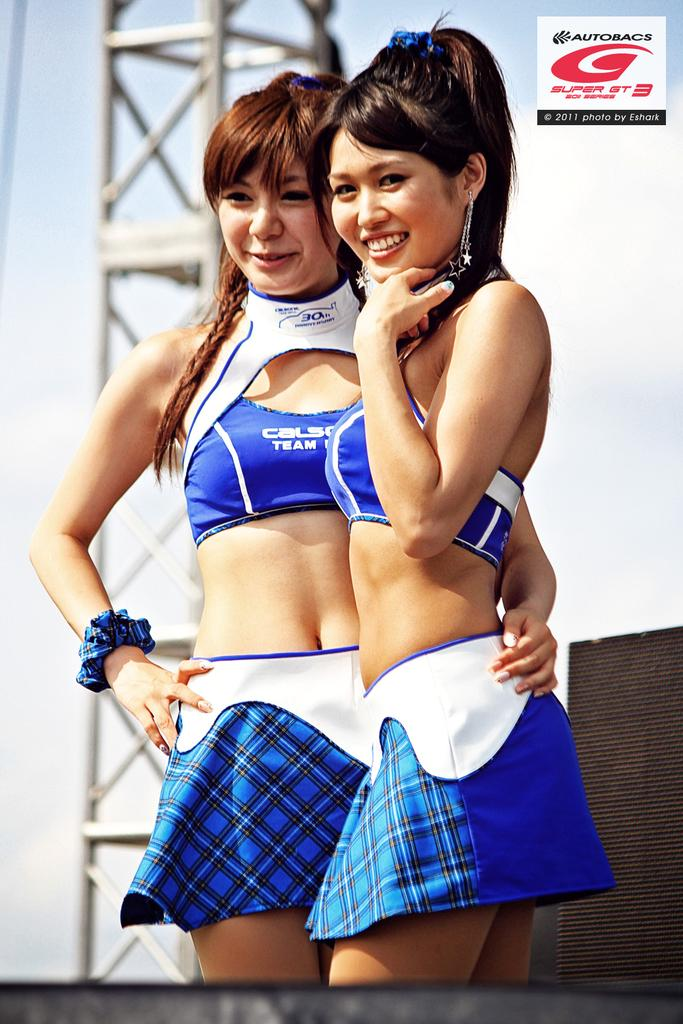<image>
Describe the image concisely. The brand shown here is Autobacs and it's their 30th anniversary 